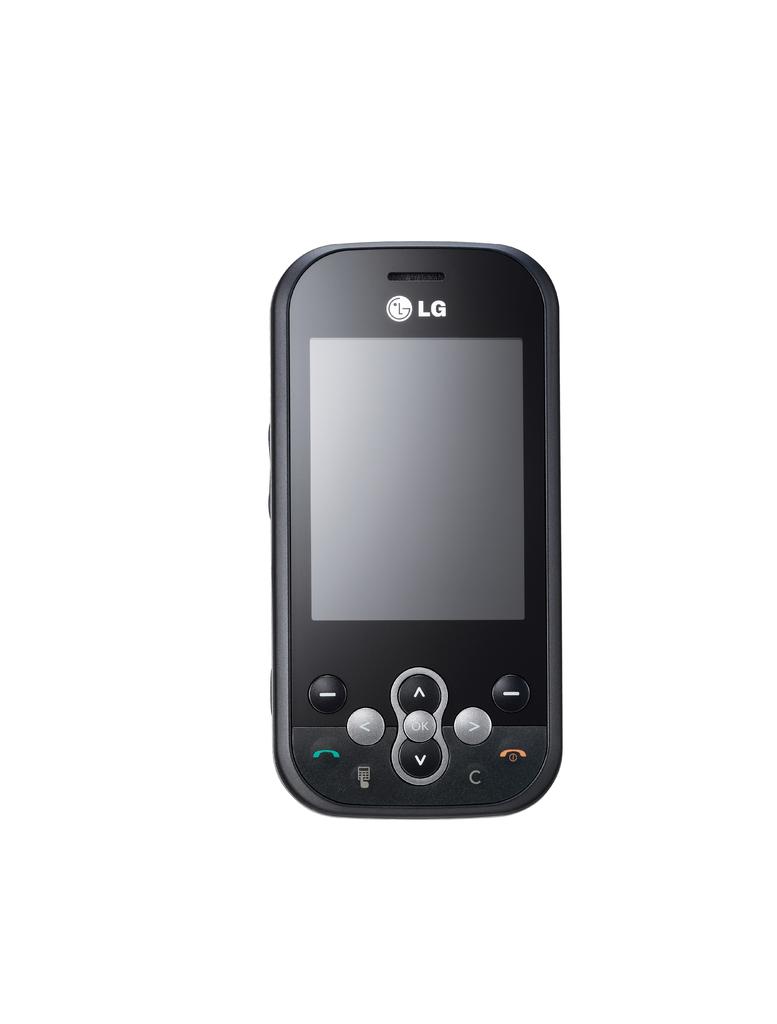What brand is this phone?
Your answer should be very brief. Lg. 